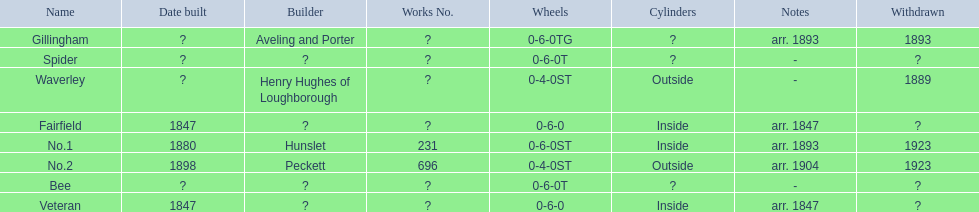Which have known built dates? Veteran, Fairfield, No.1, No.2. What other was built in 1847? Veteran. 